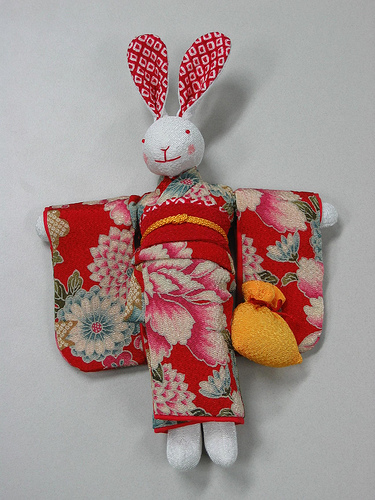<image>
Is there a rabbit in the kimono? Yes. The rabbit is contained within or inside the kimono, showing a containment relationship. 